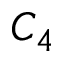Convert formula to latex. <formula><loc_0><loc_0><loc_500><loc_500>C _ { 4 }</formula> 